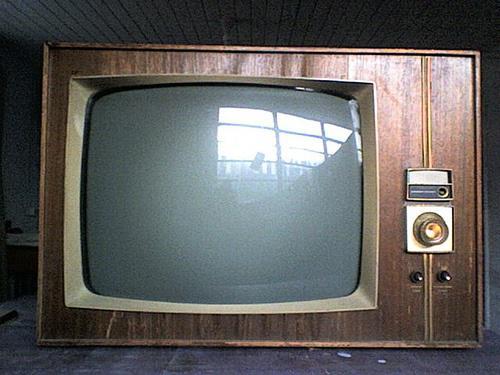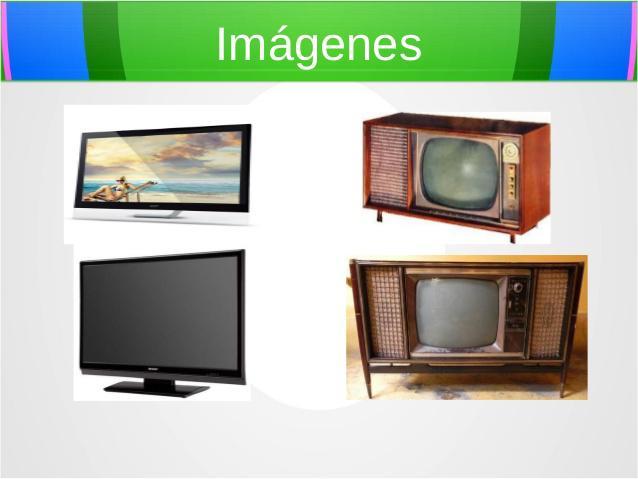The first image is the image on the left, the second image is the image on the right. Assess this claim about the two images: "In one of the images, there is only one television.". Correct or not? Answer yes or no. Yes. The first image is the image on the left, the second image is the image on the right. Examine the images to the left and right. Is the description "Multiple colorful tv's are stacked on each other" accurate? Answer yes or no. No. 